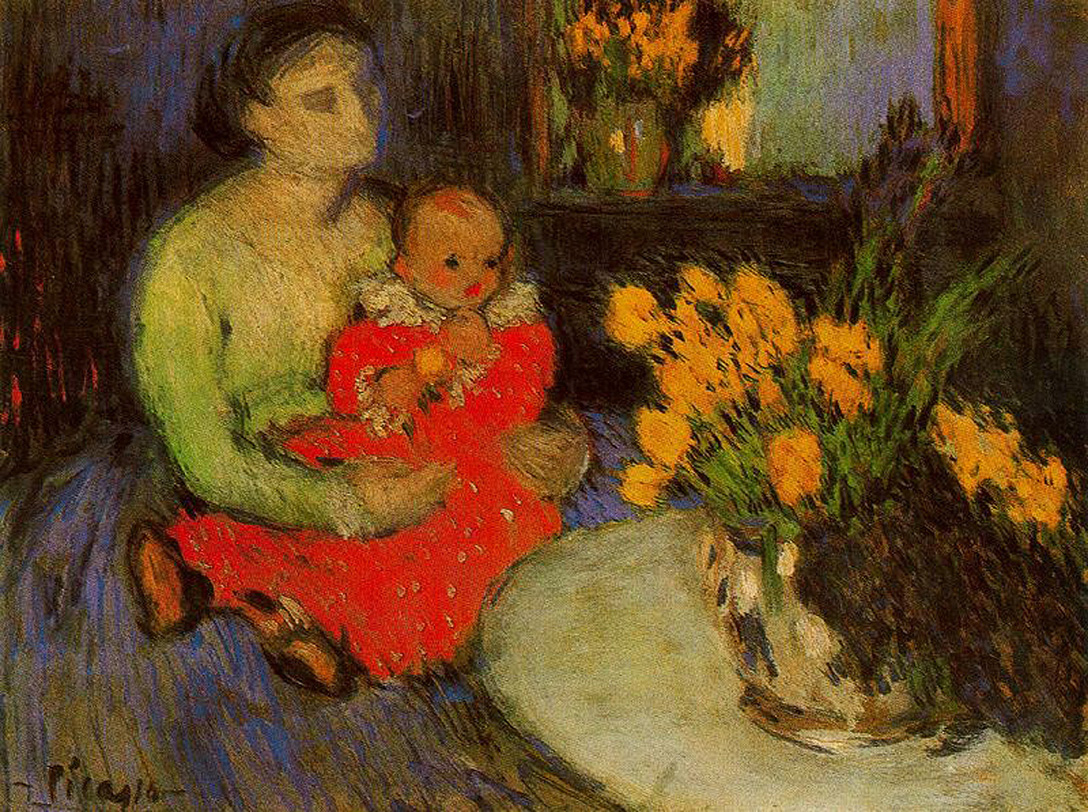What do you think is going on in this snapshot? This artwork is a stunning impressionist painting that beautifully captures a tender and intimate moment between a mother and her child. The mother, dressed in a vivid green dress, holds her child, who is adorned in a bright red dress, creating a strong visual contrast. The dim lighting of the room amplifies the vividness of their attire, further drawing the viewer's attention to the subjects. In the background, a vase of vibrant flowers adds a natural touch to the indoor setting, providing a balance to the overall composition. The artist employs loose brushstrokes, a characteristic of the impressionist style, to emphasize color and light, bringing this heartwarming scene to life. 